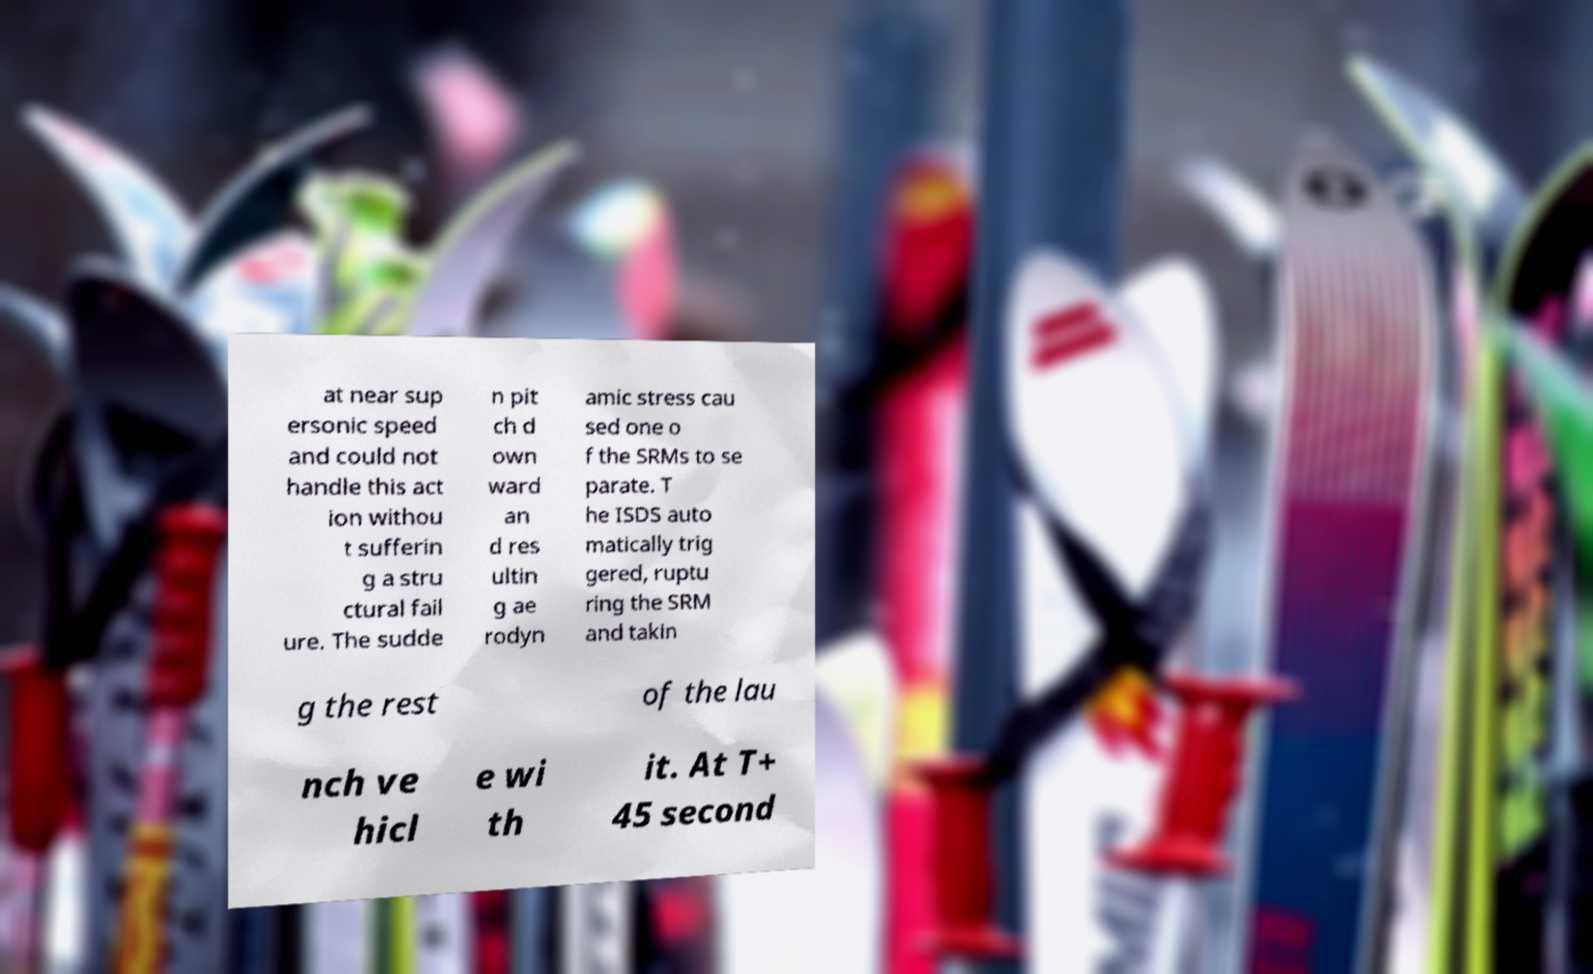Could you extract and type out the text from this image? at near sup ersonic speed and could not handle this act ion withou t sufferin g a stru ctural fail ure. The sudde n pit ch d own ward an d res ultin g ae rodyn amic stress cau sed one o f the SRMs to se parate. T he ISDS auto matically trig gered, ruptu ring the SRM and takin g the rest of the lau nch ve hicl e wi th it. At T+ 45 second 